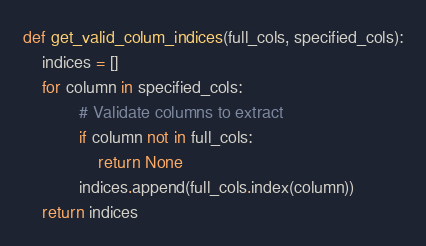<code> <loc_0><loc_0><loc_500><loc_500><_Python_>def get_valid_colum_indices(full_cols, specified_cols):
    indices = []
    for column in specified_cols:
            # Validate columns to extract
            if column not in full_cols:
                return None
            indices.append(full_cols.index(column))
    return indices</code> 